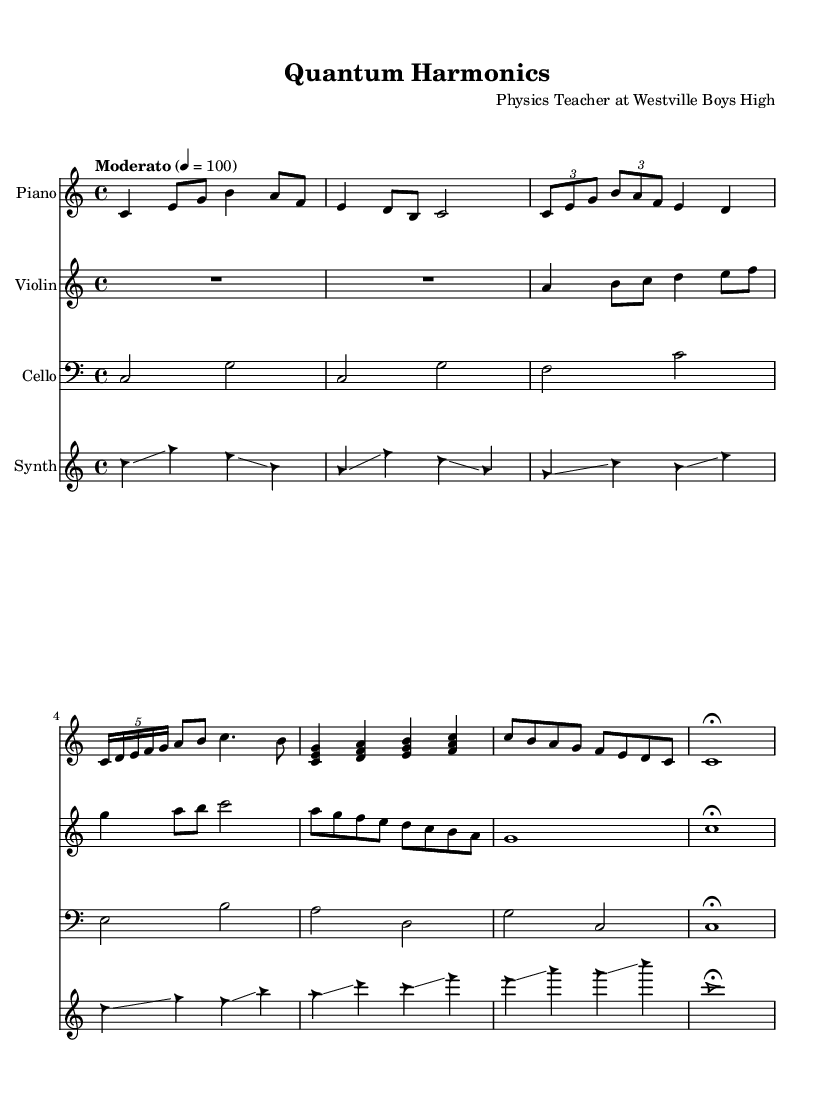What is the key signature of this music? The key signature is indicated at the beginning of the music, specifically denoted by the "c" symbol, which represents C major, having no sharps or flats.
Answer: C major What is the time signature of the piece? The time signature appears as a fraction after the key signature, specifically "4/4", indicating that there are four beats in a measure, and the quarter note gets one beat.
Answer: 4/4 What is the tempo marking given for the piece? The tempo marking is found above the music, reading "Moderato" followed by "4 = 100", which means a moderate speed of 100 beats per minute is indicated.
Answer: Moderato How many instruments are featured in this composition? By examining the score layout, there are four distinct staves for different instruments: Piano, Violin, Cello, and Synth, indicating that four instruments are used in this composition.
Answer: Four Which section of the music features a glissando? The section where glissando occurs is specified in the synthesizer part, where multiple notes are connected by the term 'glissando', emphasizing a sliding motion between notes.
Answer: Synthesizer What musical concept is represented by the tuplet in the composition? The tuplet appears in parts of the score, specifically "3/2" and "5/4", showcasing rhythmic groupings that suggest varying note values, signaling the complexity of the rhythmic structure.
Answer: Tuplet What is the final note of the piece marked with? The final note in the piano, violin, cello, and synthesizer parts is marked with a "fermata," indicating that the last note should be held longer than its usual duration, signifying the end of the composition.
Answer: Fermata 